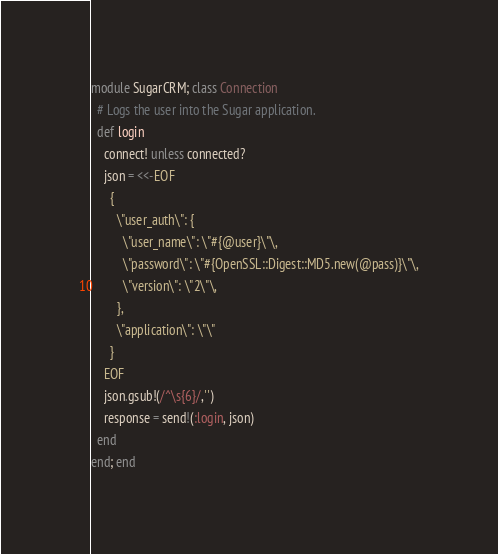<code> <loc_0><loc_0><loc_500><loc_500><_Ruby_>module SugarCRM; class Connection
  # Logs the user into the Sugar application.
  def login
    connect! unless connected?
    json = <<-EOF
      {
        \"user_auth\": {
          \"user_name\": \"#{@user}\"\,
          \"password\": \"#{OpenSSL::Digest::MD5.new(@pass)}\"\,
          \"version\": \"2\"\,
        },
        \"application\": \"\"
      }
    EOF
    json.gsub!(/^\s{6}/,'')
    response = send!(:login, json)
  end
end; end</code> 